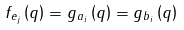<formula> <loc_0><loc_0><loc_500><loc_500>f _ { e _ { j } } \left ( q \right ) = g _ { a _ { i } } \left ( q \right ) = g _ { b _ { i } } \left ( q \right )</formula> 